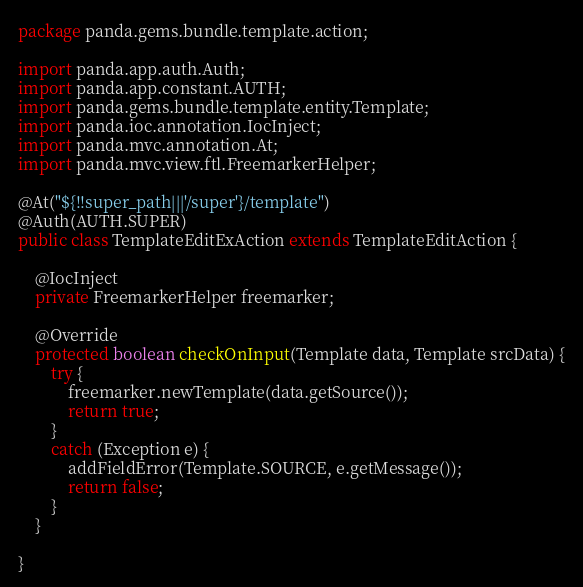<code> <loc_0><loc_0><loc_500><loc_500><_Java_>package panda.gems.bundle.template.action;

import panda.app.auth.Auth;
import panda.app.constant.AUTH;
import panda.gems.bundle.template.entity.Template;
import panda.ioc.annotation.IocInject;
import panda.mvc.annotation.At;
import panda.mvc.view.ftl.FreemarkerHelper;

@At("${!!super_path|||'/super'}/template")
@Auth(AUTH.SUPER)
public class TemplateEditExAction extends TemplateEditAction {

	@IocInject
	private FreemarkerHelper freemarker;
	
	@Override
	protected boolean checkOnInput(Template data, Template srcData) {
		try {
			freemarker.newTemplate(data.getSource());
			return true;
		}
		catch (Exception e) {
			addFieldError(Template.SOURCE, e.getMessage());
			return false;
		}
	}

}
</code> 